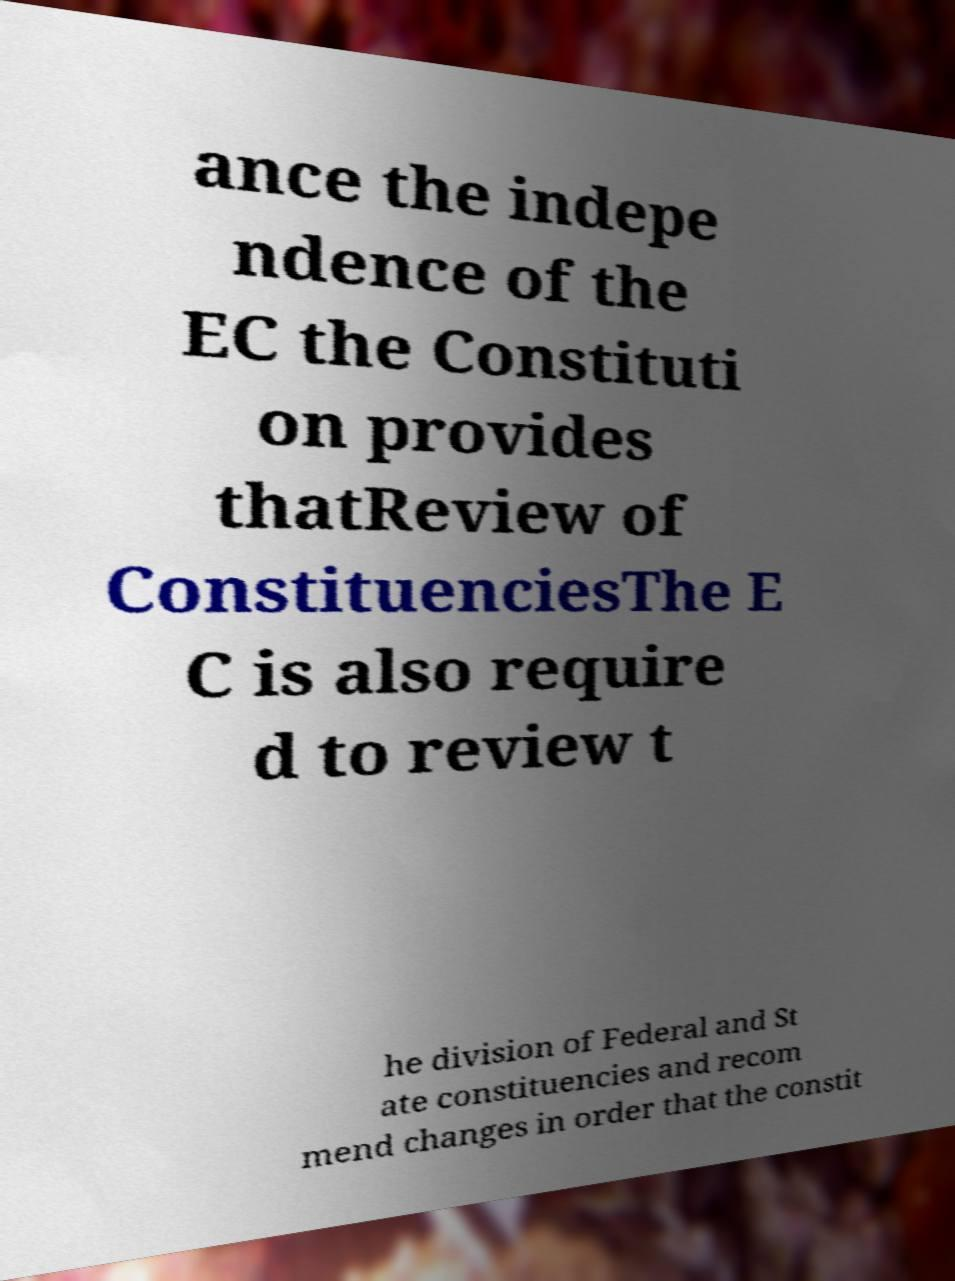There's text embedded in this image that I need extracted. Can you transcribe it verbatim? ance the indepe ndence of the EC the Constituti on provides thatReview of ConstituenciesThe E C is also require d to review t he division of Federal and St ate constituencies and recom mend changes in order that the constit 